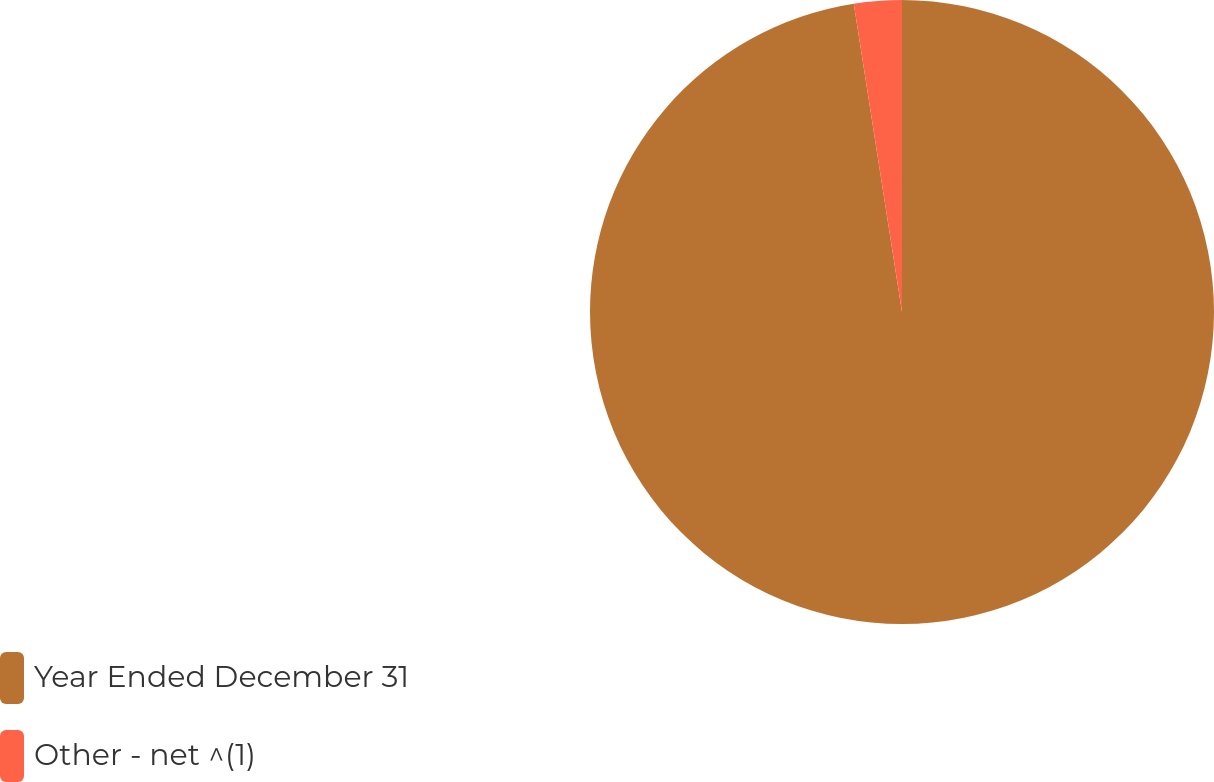Convert chart. <chart><loc_0><loc_0><loc_500><loc_500><pie_chart><fcel>Year Ended December 31<fcel>Other - net ^(1)<nl><fcel>97.53%<fcel>2.47%<nl></chart> 